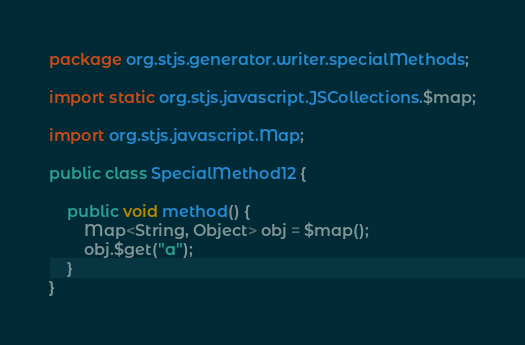Convert code to text. <code><loc_0><loc_0><loc_500><loc_500><_Java_>package org.stjs.generator.writer.specialMethods;

import static org.stjs.javascript.JSCollections.$map;

import org.stjs.javascript.Map;

public class SpecialMethod12 {

	public void method() {
		Map<String, Object> obj = $map();
		obj.$get("a");
	}
}
</code> 